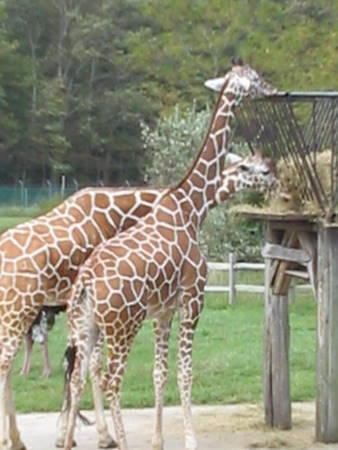How many giraffe?
Give a very brief answer. 2. How many animals are here?
Give a very brief answer. 2. How many giraffes are there?
Give a very brief answer. 2. 